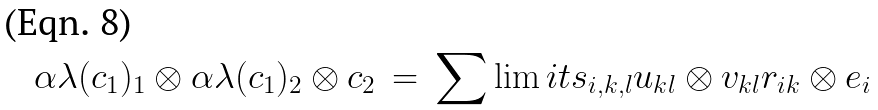Convert formula to latex. <formula><loc_0><loc_0><loc_500><loc_500>\alpha \lambda ( c _ { 1 } ) _ { 1 } \otimes \alpha \lambda ( c _ { 1 } ) _ { 2 } \otimes c _ { 2 } \, = \, \sum \lim i t s _ { i , k , l } u _ { k l } \otimes v _ { k l } r _ { i k } \otimes e _ { i }</formula> 